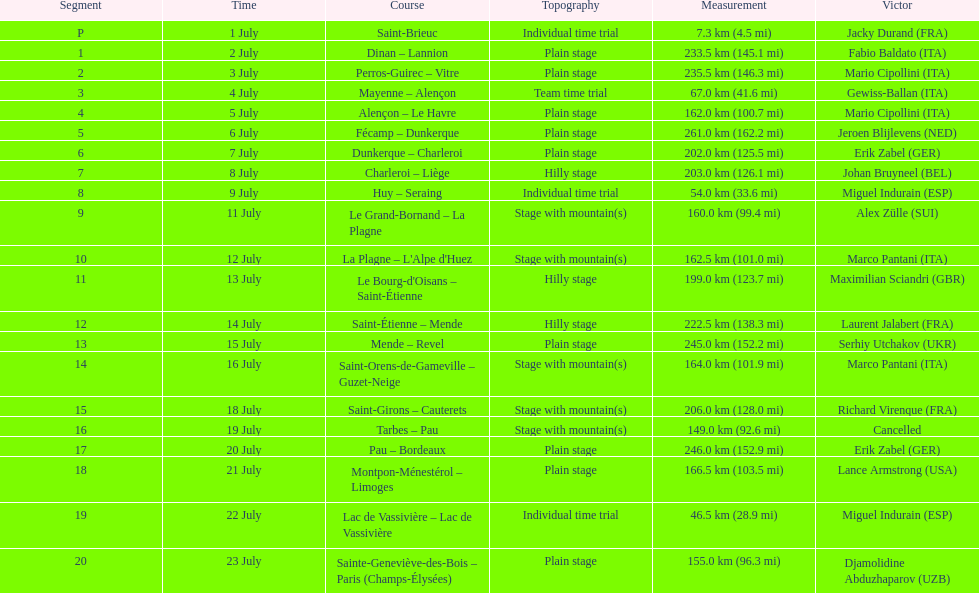After lance armstrong, who led next in the 1995 tour de france? Miguel Indurain. 